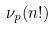<formula> <loc_0><loc_0><loc_500><loc_500>\nu _ { p } ( n ! )</formula> 